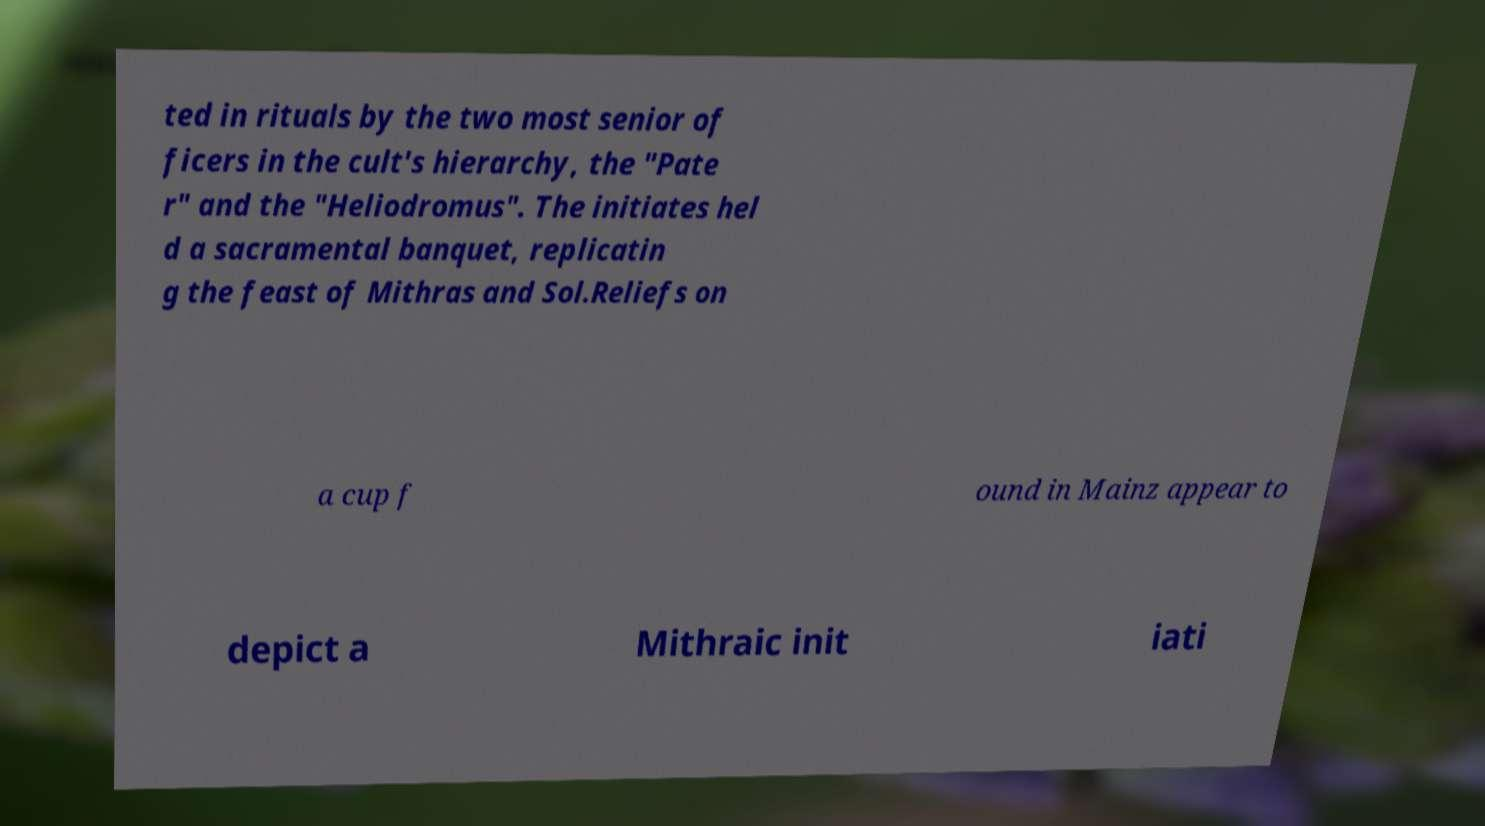Can you accurately transcribe the text from the provided image for me? ted in rituals by the two most senior of ficers in the cult's hierarchy, the "Pate r" and the "Heliodromus". The initiates hel d a sacramental banquet, replicatin g the feast of Mithras and Sol.Reliefs on a cup f ound in Mainz appear to depict a Mithraic init iati 